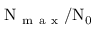<formula> <loc_0><loc_0><loc_500><loc_500>\nu _ { m a x } / \nu _ { 0 }</formula> 